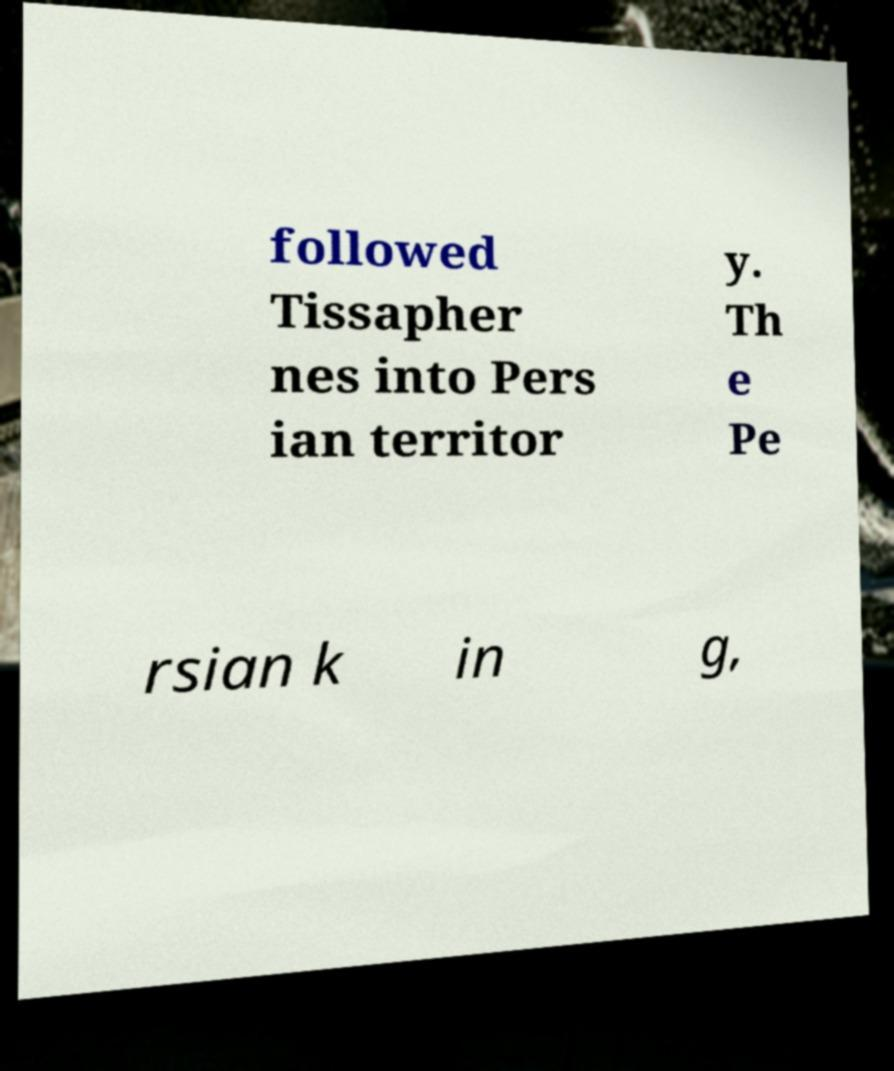I need the written content from this picture converted into text. Can you do that? followed Tissapher nes into Pers ian territor y. Th e Pe rsian k in g, 